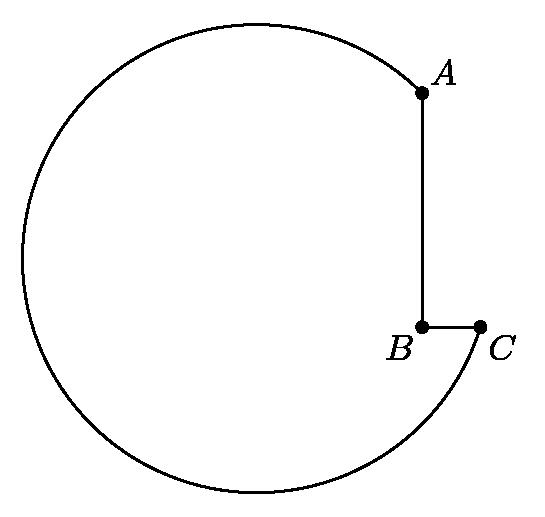A machine-shop cutting tool has the shape of a notched circle, as shown.  The radius of the circle is $\sqrt{50}$ cm, the length of $AB$ is 6 cm, and that of $BC$ is 2 cm.  The angle $ABC$ is a right angle.  Find the square of the distance (in centimeters) from $B$ to the center of the circle.
 Answer is 26. 